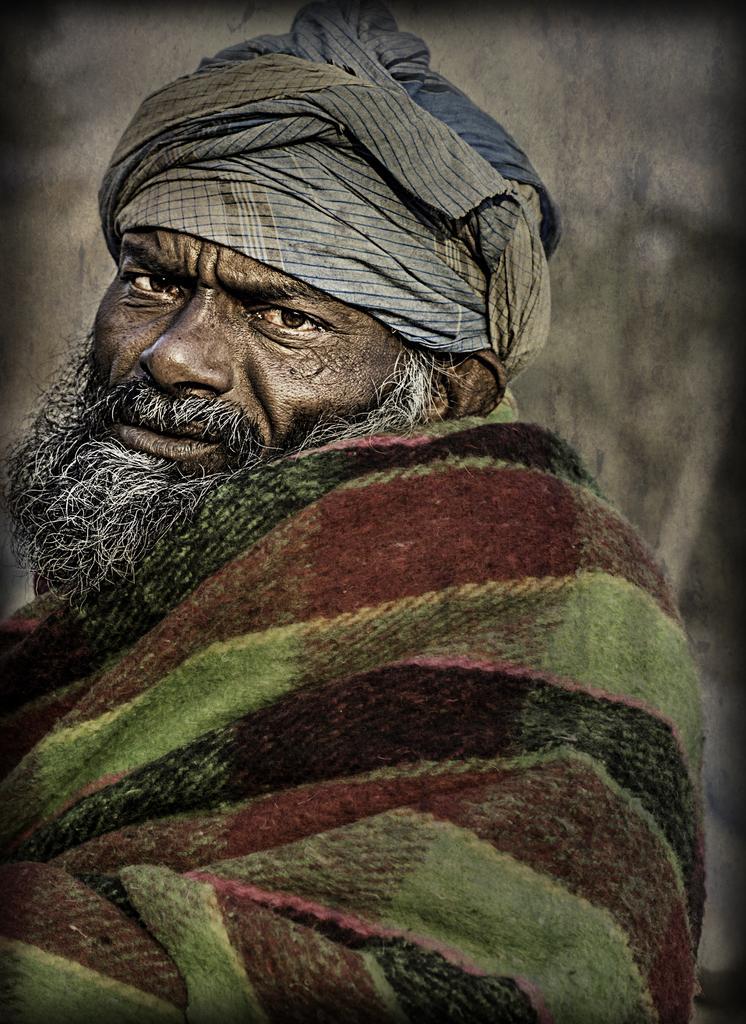Describe this image in one or two sentences. In the picture we can see an old man with mustache and beard, which is white and on him we can see a cloth and in his head we can see a turban. 